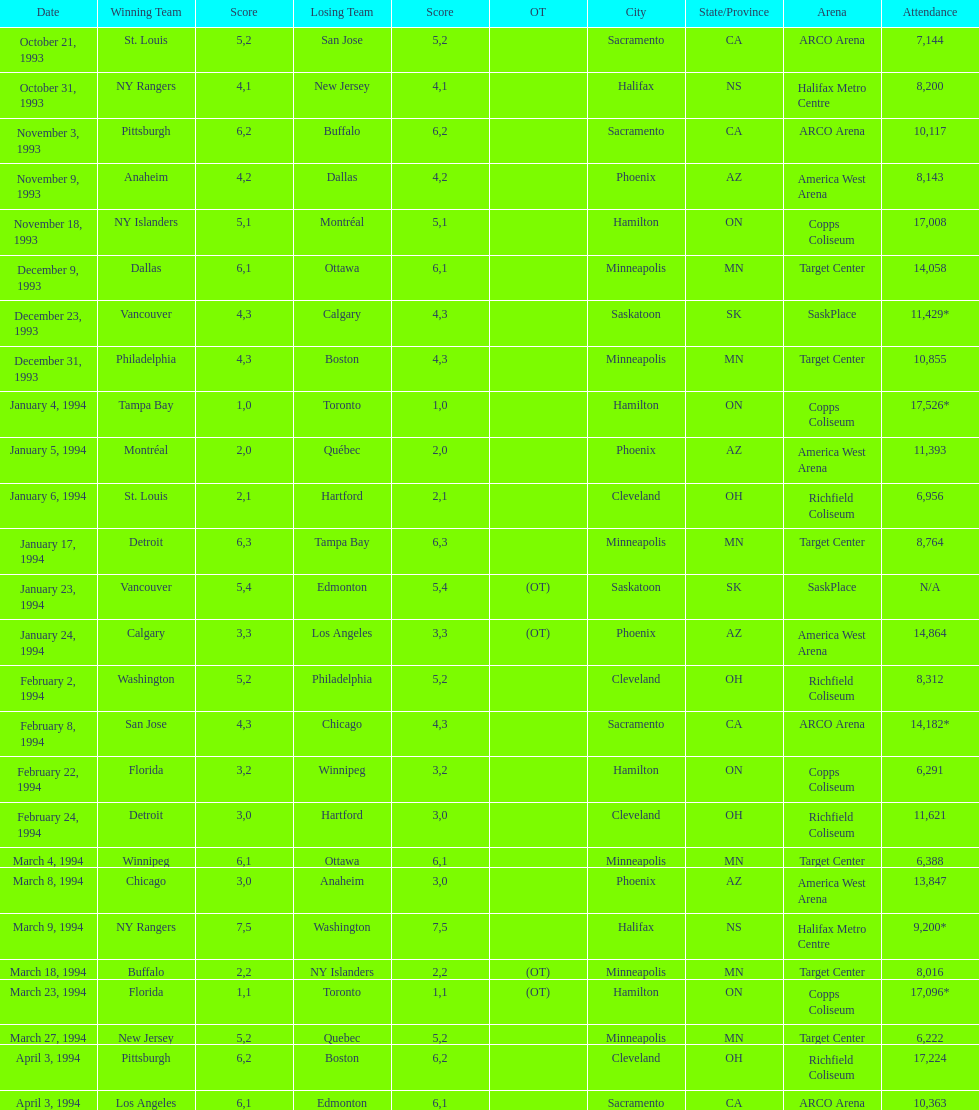What is the number of events that took place in minneapolis, mn? 6. 